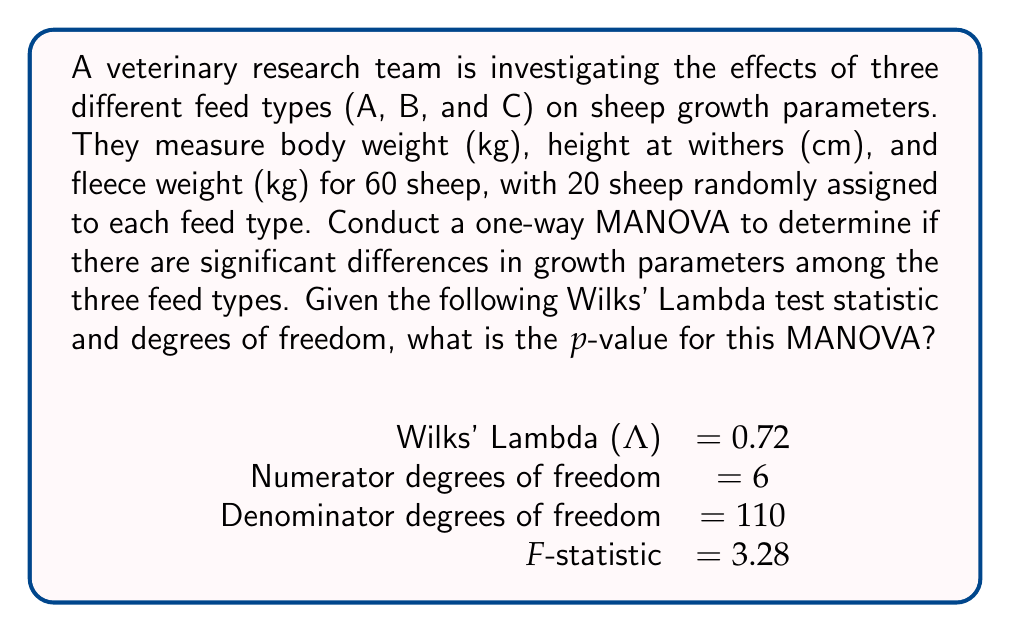Could you help me with this problem? To solve this problem, we need to follow these steps:

1. Understand the MANOVA setup:
   - Independent variable: Feed type (3 levels: A, B, C)
   - Dependent variables: Body weight, height at withers, fleece weight
   - Sample size: 60 sheep (20 per group)

2. Interpret the given information:
   - Wilks' Lambda (Λ) = 0.72
   - Numerator df = 6
   - Denominator df = 110
   - F-statistic = 3.28

3. Understand the meaning of Wilks' Lambda:
   Wilks' Lambda is a test statistic used in MANOVA to test whether there are differences between the means of identified groups on a combination of dependent variables. It ranges from 0 to 1, where values closer to 0 indicate greater differences between groups.

4. Understand the relationship between Wilks' Lambda and the F-distribution:
   The F-statistic derived from Wilks' Lambda follows an F-distribution with the given degrees of freedom.

5. Calculate the p-value:
   To find the p-value, we need to use the F-distribution with 6 numerator df and 110 denominator df. We want to find the probability of obtaining an F-value greater than or equal to 3.28.

   The p-value can be calculated using statistical software or an F-distribution calculator. Using such a tool, we find:

   p-value = P(F ≥ 3.28) ≈ 0.0052

6. Interpret the result:
   The p-value (0.0052) is less than the common significance level of 0.05, indicating strong evidence against the null hypothesis. This suggests that there are significant differences in growth parameters among the three feed types.
Answer: The p-value for the MANOVA is approximately 0.0052. 